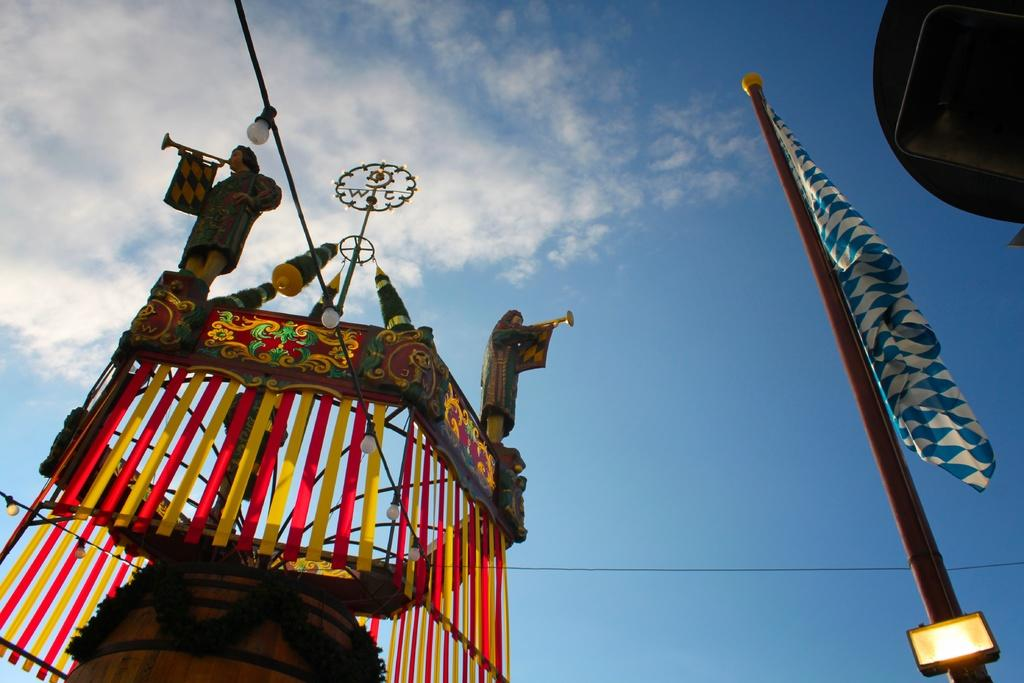What can be seen on the left side of the image? There is an object on the left side of the image. What is located on the right side of the image? There is a flag on the right side of the image. What is visible at the top of the image? The sky is visible at the top of the image. How much glue is needed to attach the object to the flag in the image? There is no mention of glue or any need to attach the object to the flag in the image. What type of calculator is being used by the person in the image? There is no person or calculator present in the image. 